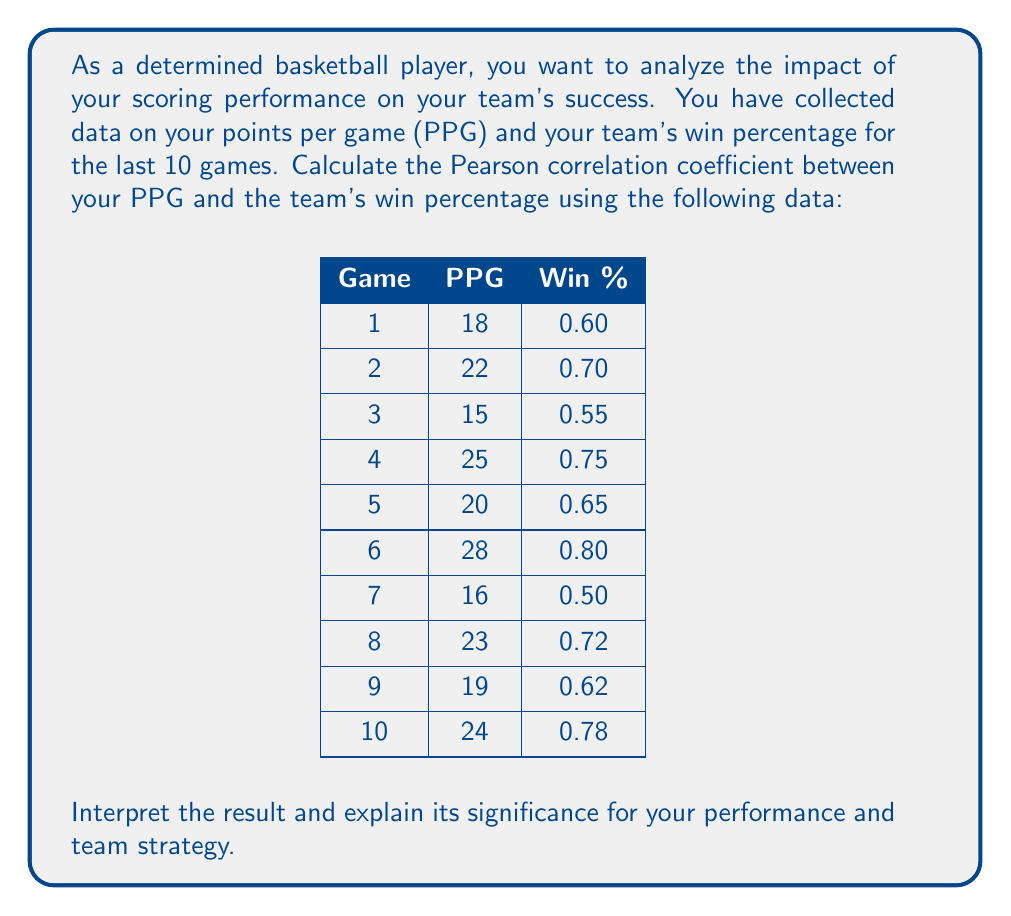Can you answer this question? To calculate the Pearson correlation coefficient between your PPG and the team's win percentage, we'll follow these steps:

1. Calculate the means of PPG ($\bar{X}$) and Win % ($\bar{Y}$):

   $\bar{X} = \frac{18 + 22 + 15 + 25 + 20 + 28 + 16 + 23 + 19 + 24}{10} = 21$
   $\bar{Y} = \frac{0.60 + 0.70 + 0.55 + 0.75 + 0.65 + 0.80 + 0.50 + 0.72 + 0.62 + 0.78}{10} = 0.667$

2. Calculate the deviations from the mean for both variables:

   Game | PPG (X) | Win % (Y) | X - $\bar{X}$ | Y - $\bar{Y}$
   1    | 18      | 0.60      | -3            | -0.067
   2    | 22      | 0.70      | 1             | 0.033
   3    | 15      | 0.55      | -6            | -0.117
   4    | 25      | 0.75      | 4             | 0.083
   5    | 20      | 0.65      | -1            | -0.017
   6    | 28      | 0.80      | 7             | 0.133
   7    | 16      | 0.50      | -5            | -0.167
   8    | 23      | 0.72      | 2             | 0.053
   9    | 19      | 0.62      | -2            | -0.047
   10   | 24      | 0.78      | 3             | 0.113

3. Calculate the sum of products of deviations, and the sum of squared deviations:

   $\sum (X - \bar{X})(Y - \bar{Y}) = 3.944$
   $\sum (X - \bar{X})^2 = 180$
   $\sum (Y - \bar{Y})^2 = 0.09446$

4. Apply the Pearson correlation coefficient formula:

   $r = \frac{\sum (X - \bar{X})(Y - \bar{Y})}{\sqrt{\sum (X - \bar{X})^2 \sum (Y - \bar{Y})^2}}$

   $r = \frac{3.944}{\sqrt{180 \times 0.09446}} = \frac{3.944}{4.1226} = 0.9567$

The Pearson correlation coefficient is approximately 0.9567.

Interpretation:
The correlation coefficient ranges from -1 to 1, where:
- 1 indicates a perfect positive correlation
- 0 indicates no correlation
- -1 indicates a perfect negative correlation

A value of 0.9567 indicates a very strong positive correlation between your PPG and the team's win percentage. This means that as your scoring performance increases, the team's win percentage tends to increase as well.

Significance:
1. Your scoring performance has a substantial impact on your team's success.
2. Focusing on improving your scoring ability could lead to more team wins.
3. The team strategy should involve creating opportunities for you to score.
4. However, it's important to remember that correlation doesn't imply causation. Other factors may also contribute to the team's success.
5. This analysis can motivate you to maintain high performance and take on a leadership role in scoring.
Answer: The Pearson correlation coefficient between PPG and team win percentage is approximately 0.9567, indicating a very strong positive correlation between your scoring performance and the team's success. 